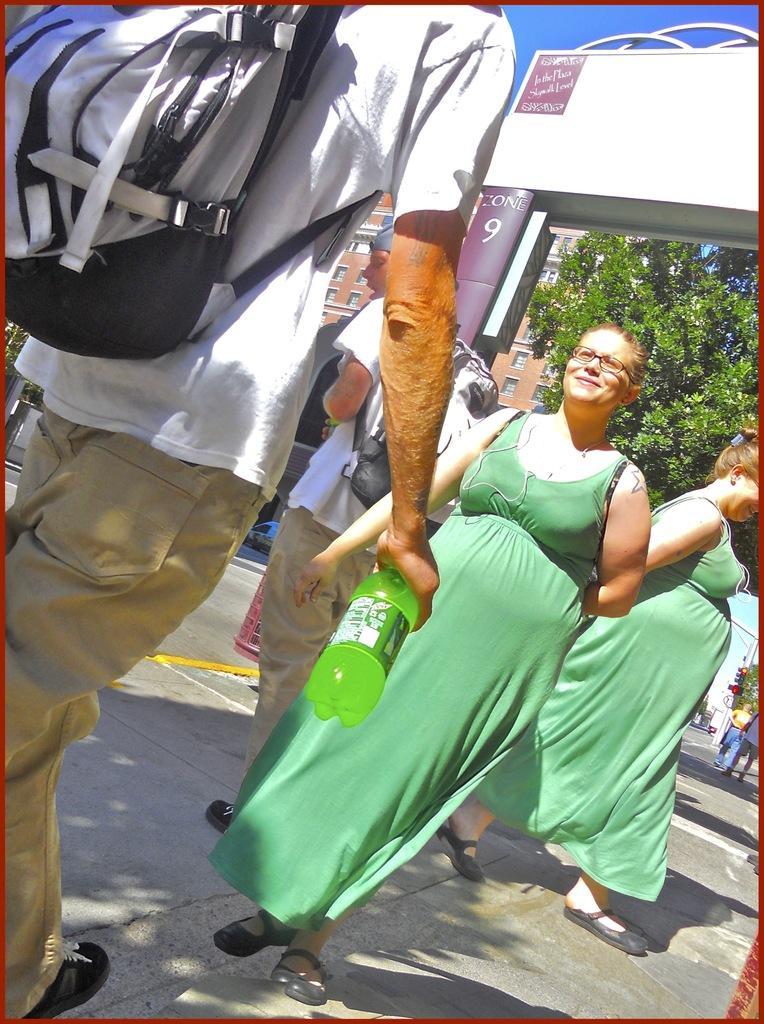How would you summarize this image in a sentence or two? Here men and women are walking. This is bag, bottle and a tree. This is a building with the windows, this is sky. 